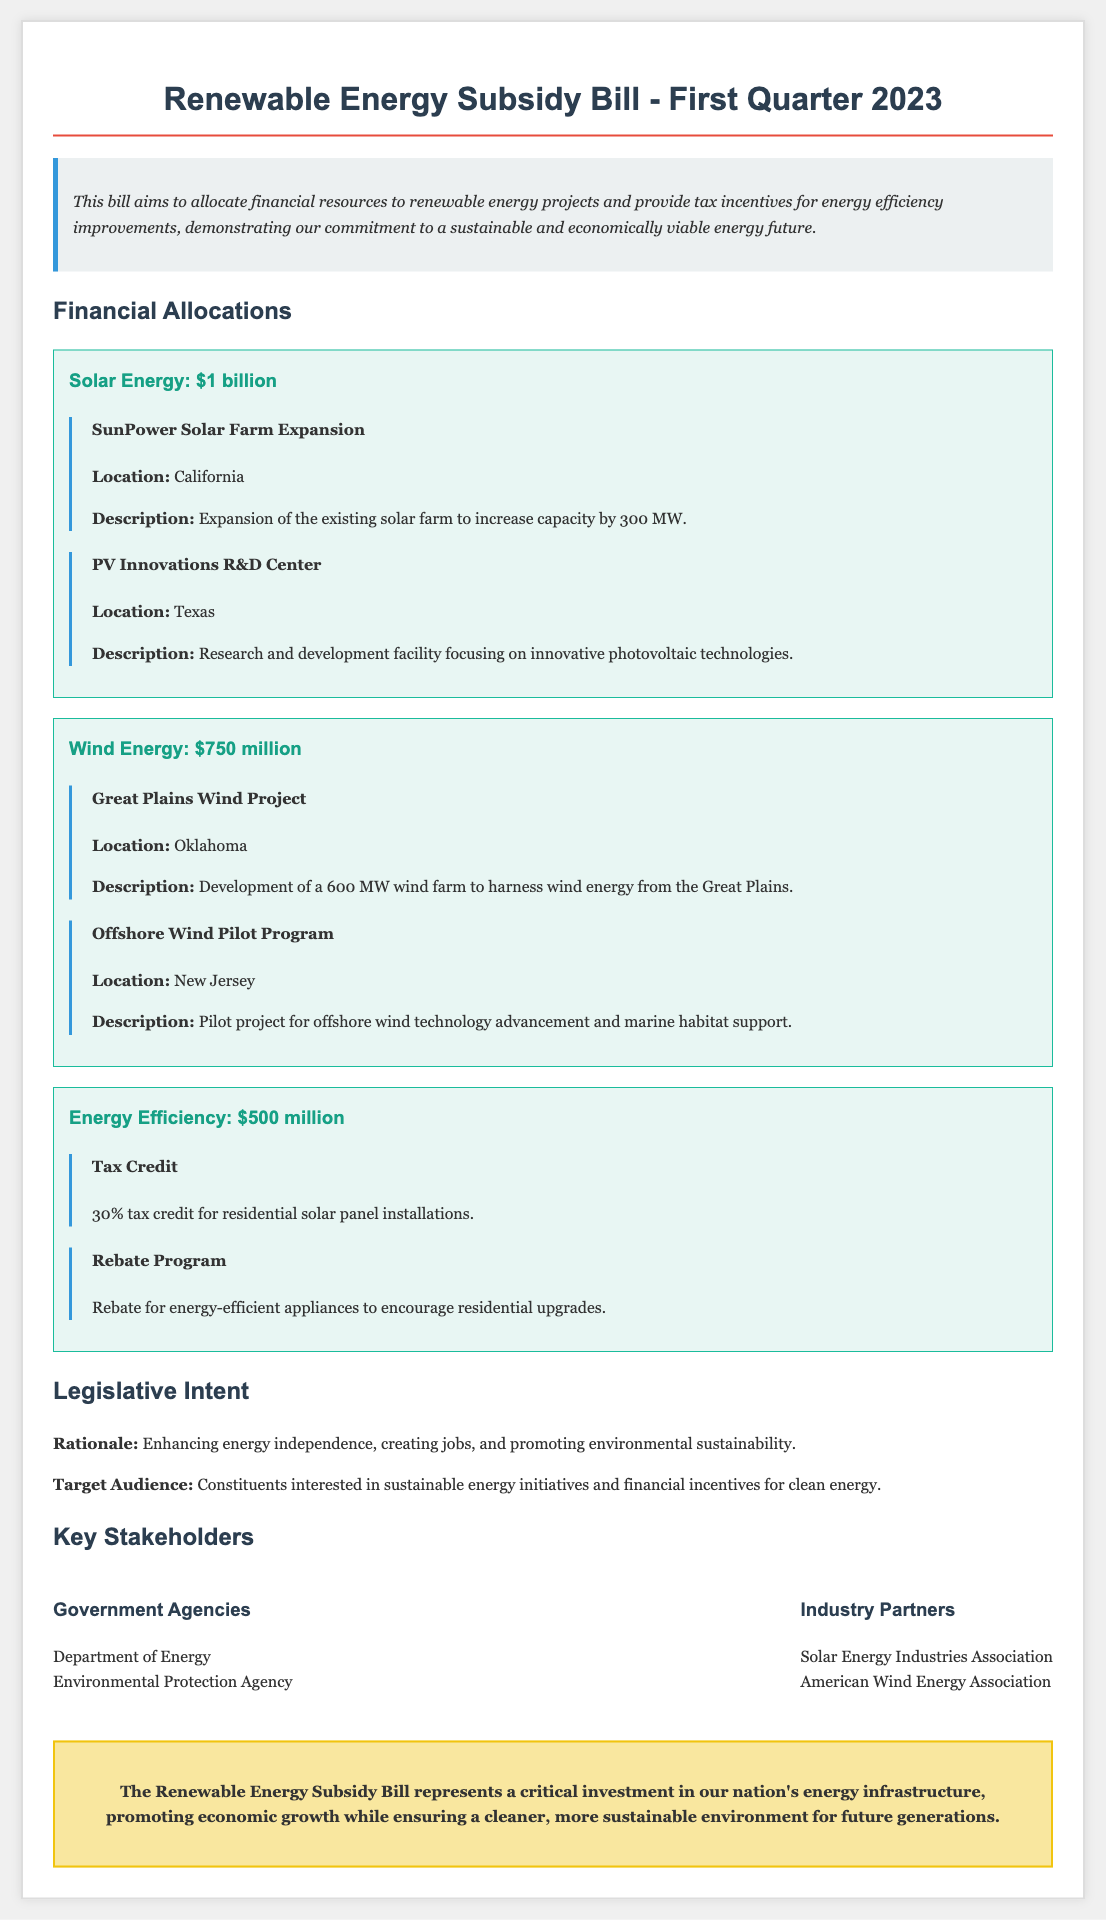What is the total allocation for solar energy? The total allocation for solar energy is stated in the bill as $1 billion.
Answer: $1 billion How much funding is allocated to wind energy projects? The funding allocated to wind energy projects is listed in the document as $750 million.
Answer: $750 million What is one project included in the solar energy allocation? The document mentions the "SunPower Solar Farm Expansion" as one of the projects included in the solar energy allocation.
Answer: SunPower Solar Farm Expansion What tax incentive is offered for residential solar panel installations? The bill specifies a 30% tax credit for residential solar panel installations as a tax incentive.
Answer: 30% tax credit What is the purpose of the Renewable Energy Subsidy Bill? The bill is designed to promote sustainable energy initiatives and provide financial incentives for clean energy.
Answer: Promote sustainable energy initiatives What is the total funding for energy efficiency improvements? The total funding for energy efficiency improvements is outlined in the document as $500 million.
Answer: $500 million Where is the Great Plains Wind Project located? The Great Plains Wind Project is located in Oklahoma, according to the document.
Answer: Oklahoma Who are two key stakeholders mentioned in the bill? "Department of Energy" and "Environmental Protection Agency" are listed as key stakeholders in the bill.
Answer: Department of Energy, Environmental Protection Agency What is one type of rebate program included for energy efficiency? The document mentions a rebate for energy-efficient appliances as a type of rebate program for energy efficiency improvements.
Answer: Rebate for energy-efficient appliances 